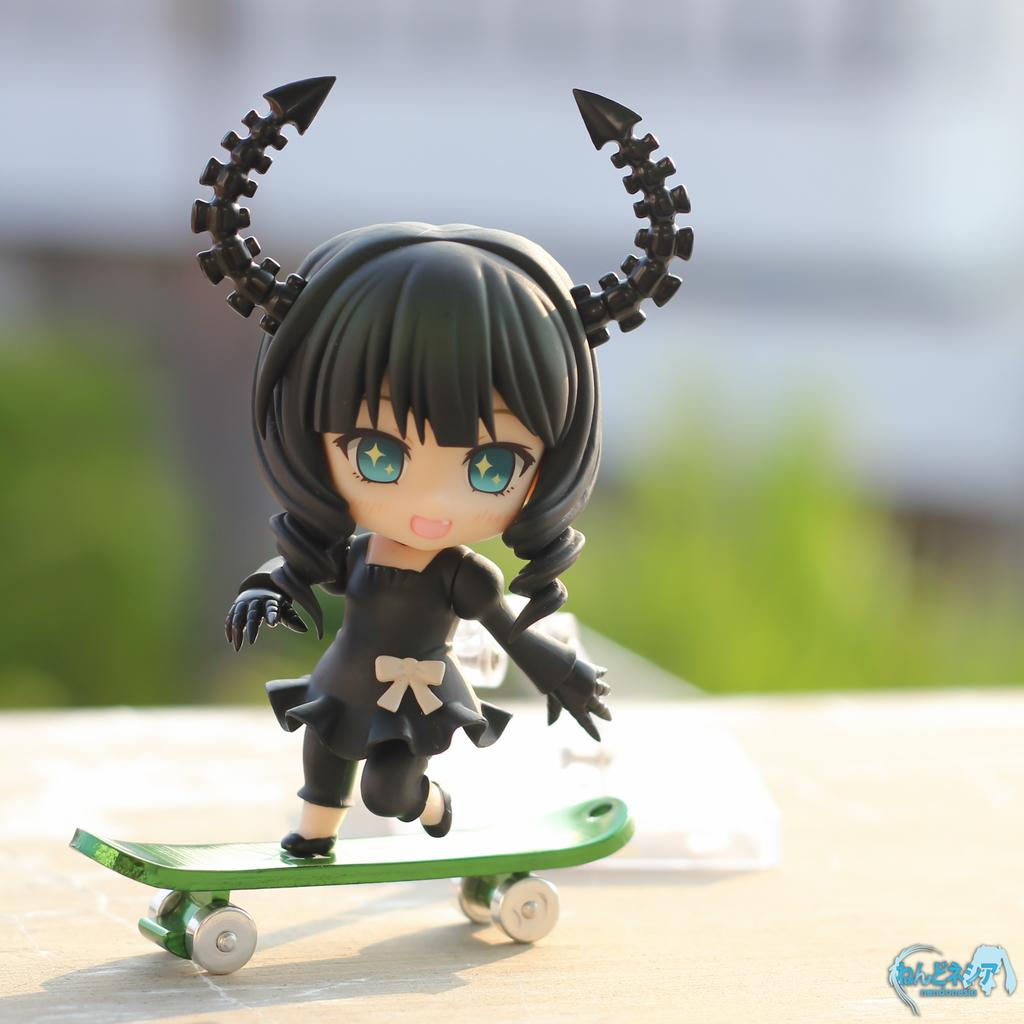What is the main subject of the subject of the image? The main subject of the image is a toy of a girl. What is the toy doing in the image? The toy is standing on a skateboard. Can you describe the background of the image? The background of the image is blurred. Is there any additional information or branding on the image? Yes, there is a watermark on the image. Can you tell me how many friends are present with the toy in the image? There are no friends present with the toy in the image; it is the main subject and is standing on a skateboard. What type of toothbrush is the toy using in the image? There is no toothbrush present in the image; the toy is standing on a skateboard. 